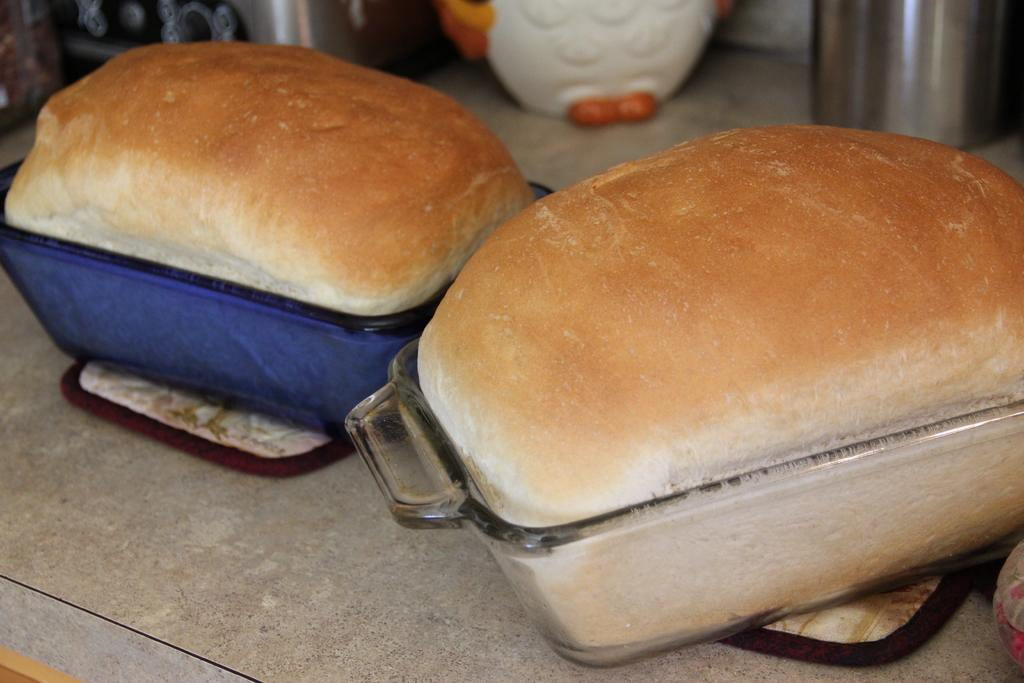What type of food can be seen in the image? There are buns in glass bowls in the image. What else can be seen in the image besides the buns? There are containers in the image. What is on the table in the image? There are mats on the table in the image. What type of drum is visible on the table in the image? There is no drum present in the image; it features buns in glass bowls, containers, and mats on the table. What mark can be seen on the buns in the image? There is no mark visible on the buns in the image; they appear to be plain. 